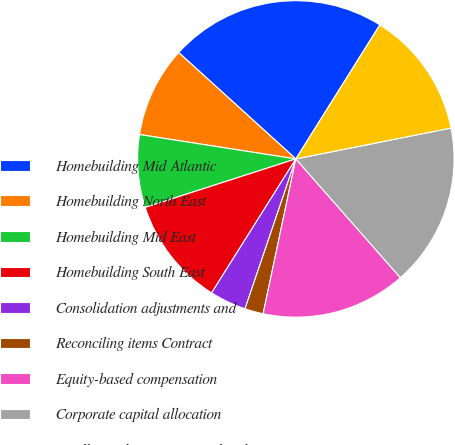Convert chart to OTSL. <chart><loc_0><loc_0><loc_500><loc_500><pie_chart><fcel>Homebuilding Mid Atlantic<fcel>Homebuilding North East<fcel>Homebuilding Mid East<fcel>Homebuilding South East<fcel>Consolidation adjustments and<fcel>Reconciling items Contract<fcel>Equity-based compensation<fcel>Corporate capital allocation<fcel>Unallocated corporate overhead<nl><fcel>22.18%<fcel>9.27%<fcel>7.42%<fcel>11.11%<fcel>3.73%<fcel>1.89%<fcel>14.8%<fcel>16.64%<fcel>12.96%<nl></chart> 